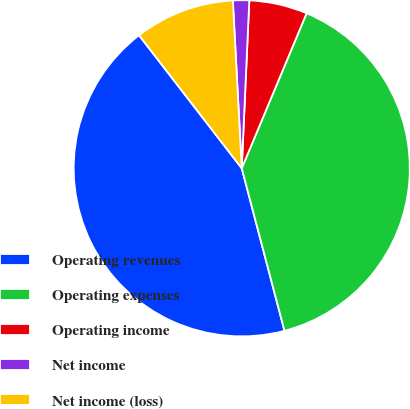<chart> <loc_0><loc_0><loc_500><loc_500><pie_chart><fcel>Operating revenues<fcel>Operating expenses<fcel>Operating income<fcel>Net income<fcel>Net income (loss)<nl><fcel>43.63%<fcel>39.6%<fcel>5.59%<fcel>1.56%<fcel>9.62%<nl></chart> 